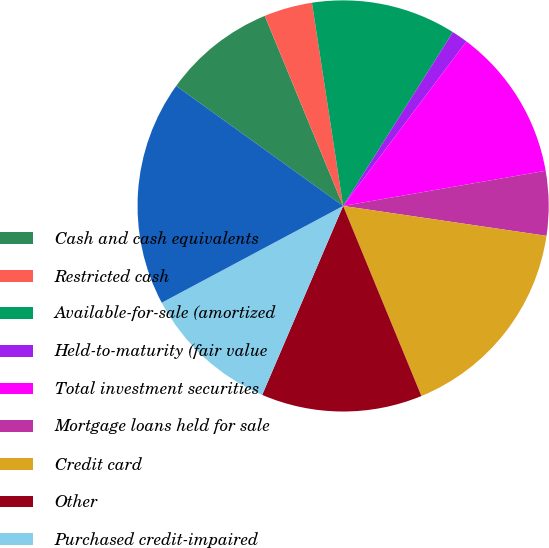Convert chart to OTSL. <chart><loc_0><loc_0><loc_500><loc_500><pie_chart><fcel>Cash and cash equivalents<fcel>Restricted cash<fcel>Available-for-sale (amortized<fcel>Held-to-maturity (fair value<fcel>Total investment securities<fcel>Mortgage loans held for sale<fcel>Credit card<fcel>Other<fcel>Purchased credit-impaired<fcel>Total loan portfolio<nl><fcel>8.86%<fcel>3.8%<fcel>11.39%<fcel>1.27%<fcel>12.03%<fcel>5.06%<fcel>16.46%<fcel>12.66%<fcel>10.76%<fcel>17.72%<nl></chart> 